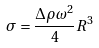<formula> <loc_0><loc_0><loc_500><loc_500>\sigma = \frac { \Delta \rho \omega ^ { 2 } } { 4 } R ^ { 3 }</formula> 